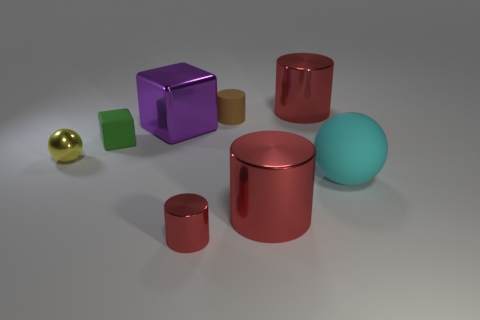There is a rubber thing that is both to the right of the purple metal object and behind the big cyan matte object; what is its color?
Your answer should be very brief. Brown. Do the cylinder behind the brown cylinder and the small shiny cylinder have the same color?
Ensure brevity in your answer.  Yes. What number of spheres are either big blue metal things or cyan things?
Keep it short and to the point. 1. There is a small matte object that is behind the big purple cube; what is its shape?
Keep it short and to the point. Cylinder. What is the color of the large cylinder that is behind the large red cylinder left of the red thing that is behind the cyan thing?
Offer a very short reply. Red. Is the tiny block made of the same material as the large sphere?
Make the answer very short. Yes. How many green objects are either rubber spheres or tiny metal cylinders?
Provide a short and direct response. 0. There is a small cube; how many small rubber blocks are behind it?
Offer a very short reply. 0. Is the number of big green matte blocks greater than the number of red metallic things?
Your answer should be very brief. No. There is a red thing that is left of the large red object in front of the green block; what shape is it?
Make the answer very short. Cylinder. 